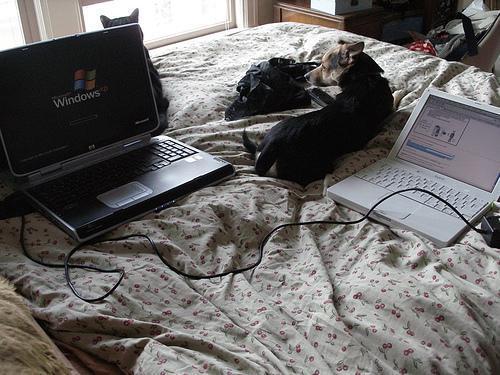How many computers are on the bed?
Give a very brief answer. 2. How many animals are on the bed?
Give a very brief answer. 2. How many laptops are there?
Give a very brief answer. 2. 